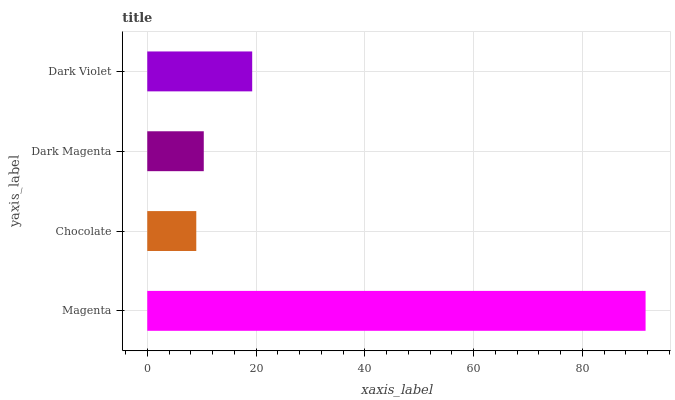Is Chocolate the minimum?
Answer yes or no. Yes. Is Magenta the maximum?
Answer yes or no. Yes. Is Dark Magenta the minimum?
Answer yes or no. No. Is Dark Magenta the maximum?
Answer yes or no. No. Is Dark Magenta greater than Chocolate?
Answer yes or no. Yes. Is Chocolate less than Dark Magenta?
Answer yes or no. Yes. Is Chocolate greater than Dark Magenta?
Answer yes or no. No. Is Dark Magenta less than Chocolate?
Answer yes or no. No. Is Dark Violet the high median?
Answer yes or no. Yes. Is Dark Magenta the low median?
Answer yes or no. Yes. Is Dark Magenta the high median?
Answer yes or no. No. Is Magenta the low median?
Answer yes or no. No. 